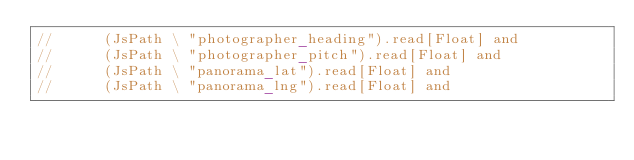<code> <loc_0><loc_0><loc_500><loc_500><_Scala_>//      (JsPath \ "photographer_heading").read[Float] and
//      (JsPath \ "photographer_pitch").read[Float] and
//      (JsPath \ "panorama_lat").read[Float] and
//      (JsPath \ "panorama_lng").read[Float] and</code> 